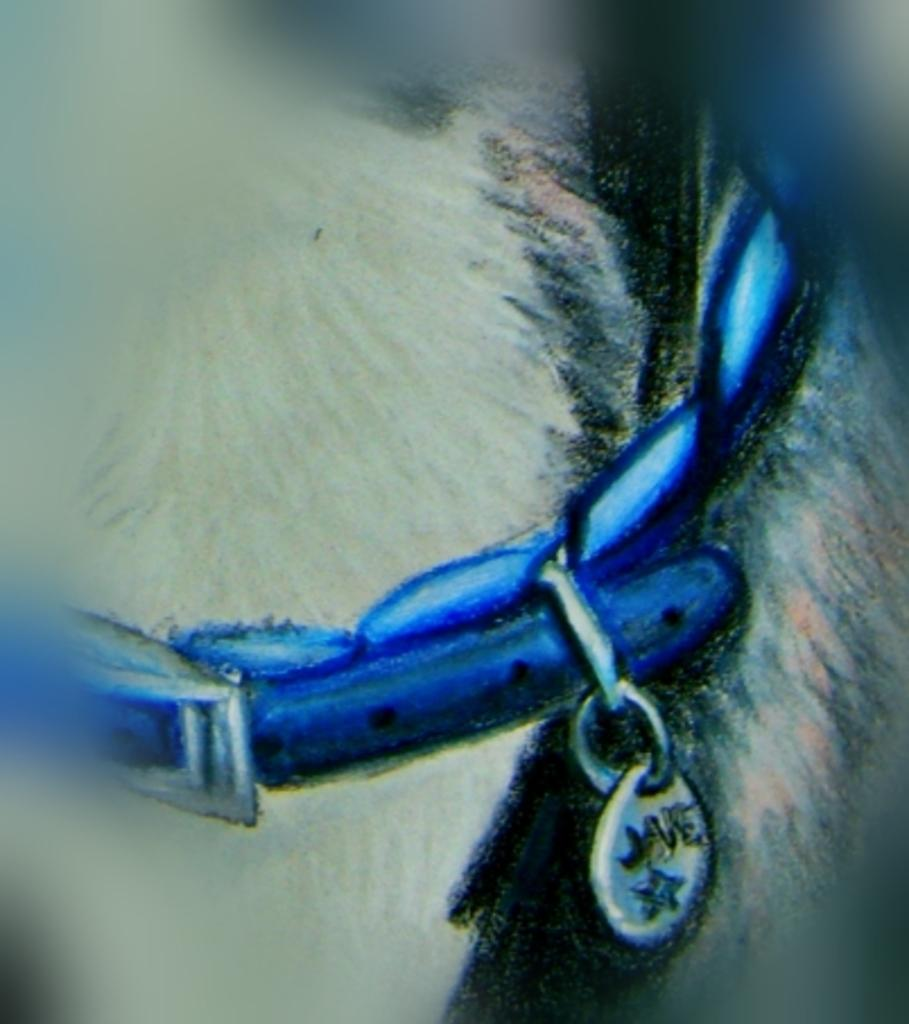What is depicted in the image? There is a picture of a belt in the image. What type of belt is shown in the picture? The belt is for an animal. What is the plot of the story involving the balloon in the image? There is no balloon present in the image, so there is no story or plot involving a balloon. 